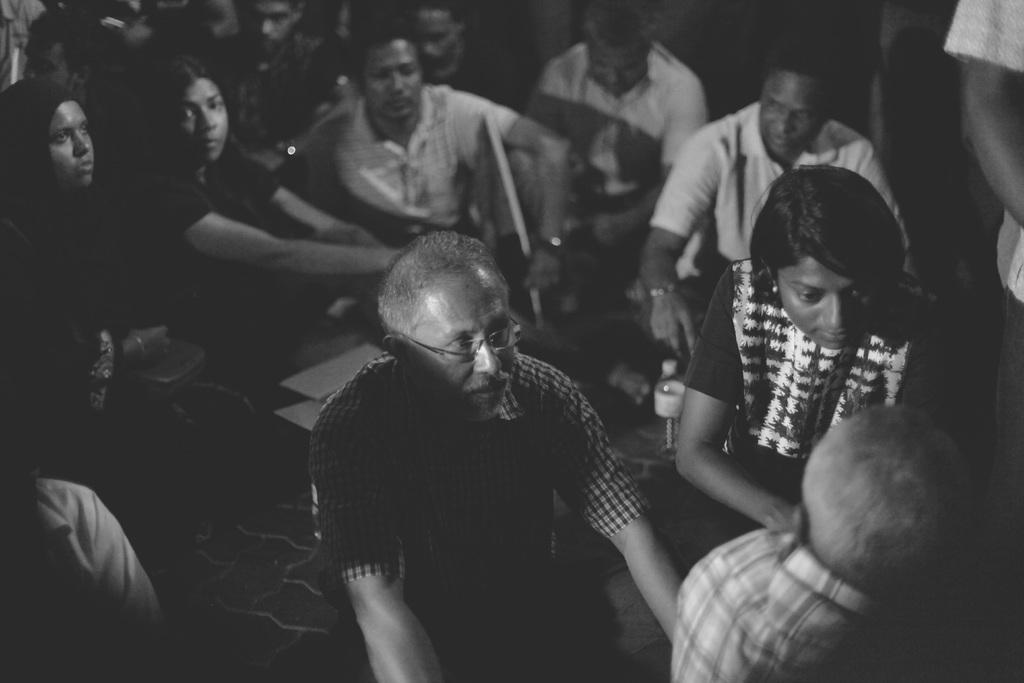In one or two sentences, can you explain what this image depicts? This is a black and white image. There are people sitting on the floor in the image. 